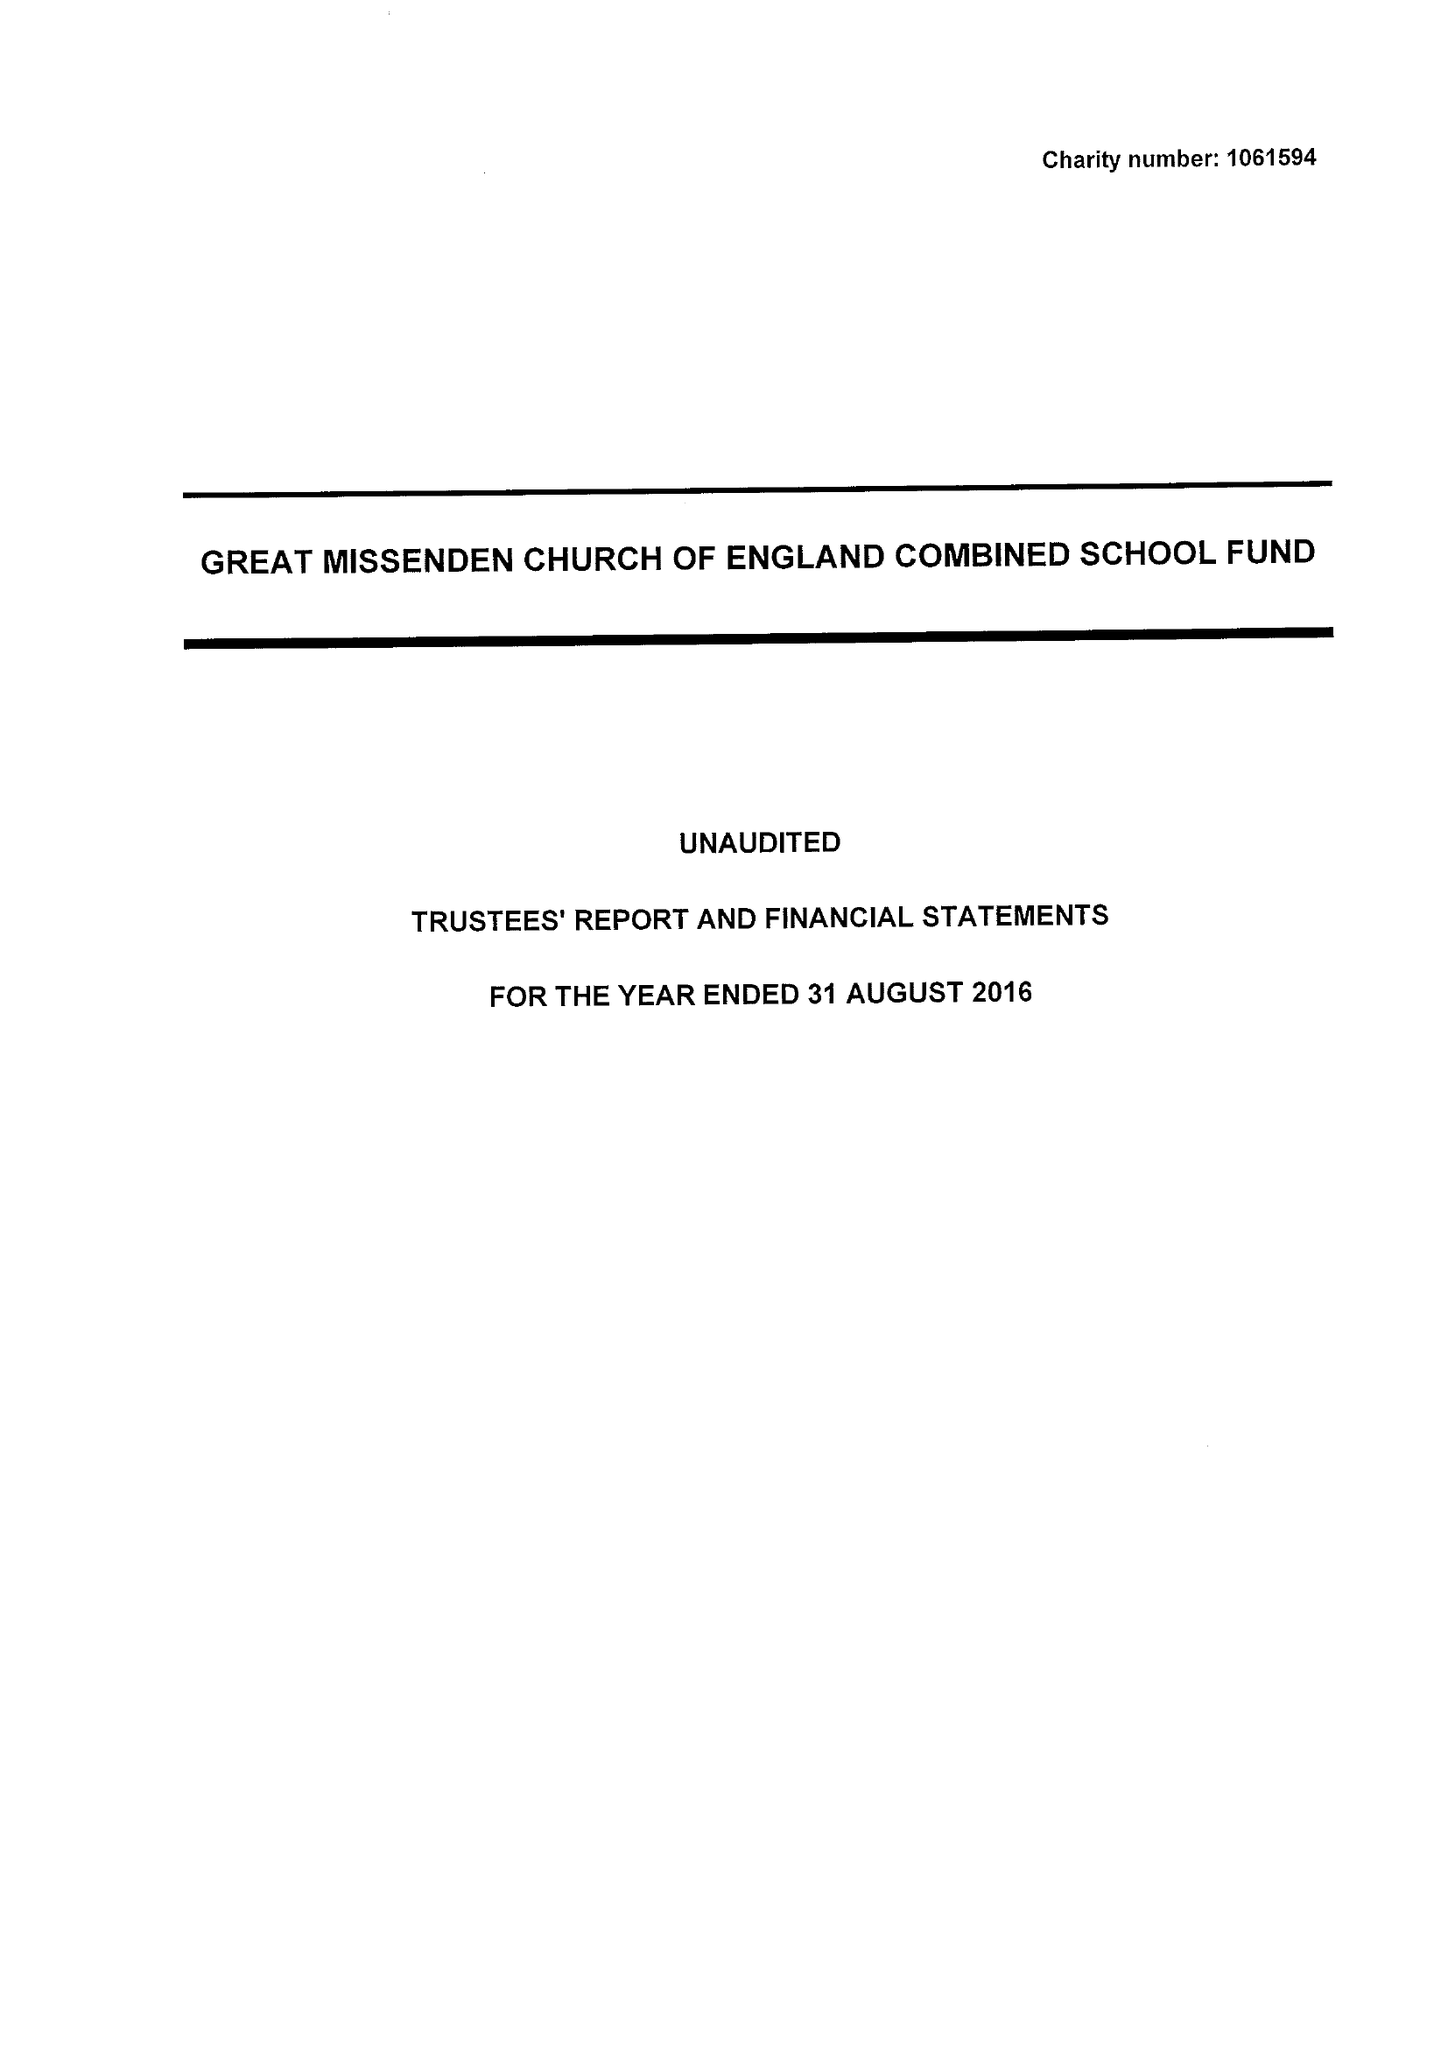What is the value for the address__post_town?
Answer the question using a single word or phrase. GREAT MISSENDEN 